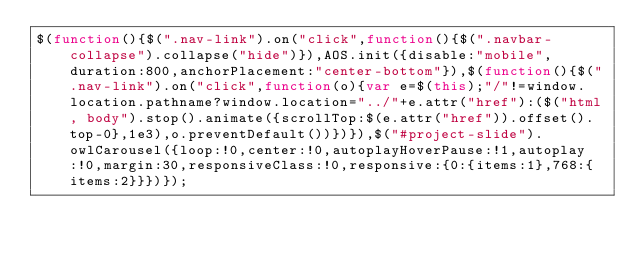Convert code to text. <code><loc_0><loc_0><loc_500><loc_500><_JavaScript_>$(function(){$(".nav-link").on("click",function(){$(".navbar-collapse").collapse("hide")}),AOS.init({disable:"mobile",duration:800,anchorPlacement:"center-bottom"}),$(function(){$(".nav-link").on("click",function(o){var e=$(this);"/"!=window.location.pathname?window.location="../"+e.attr("href"):($("html, body").stop().animate({scrollTop:$(e.attr("href")).offset().top-0},1e3),o.preventDefault())})}),$("#project-slide").owlCarousel({loop:!0,center:!0,autoplayHoverPause:!1,autoplay:!0,margin:30,responsiveClass:!0,responsive:{0:{items:1},768:{items:2}}})});</code> 